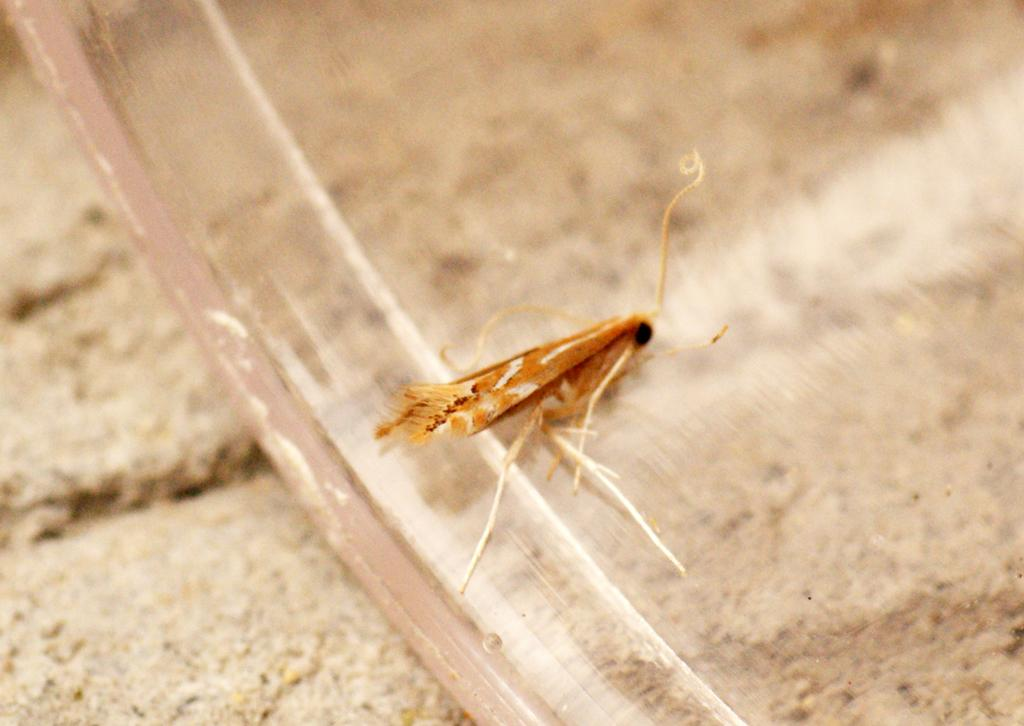What type of creature can be seen in the image? There is an insect in the image. Where is the insect located? The insect is on an object. What is the surface on which the object is placed? The object is on the land. What type of wine is being served at the nighttime rhythm event in the image? There is no wine, nighttime, or rhythm event present in the image; it features an insect on an object on the land. 